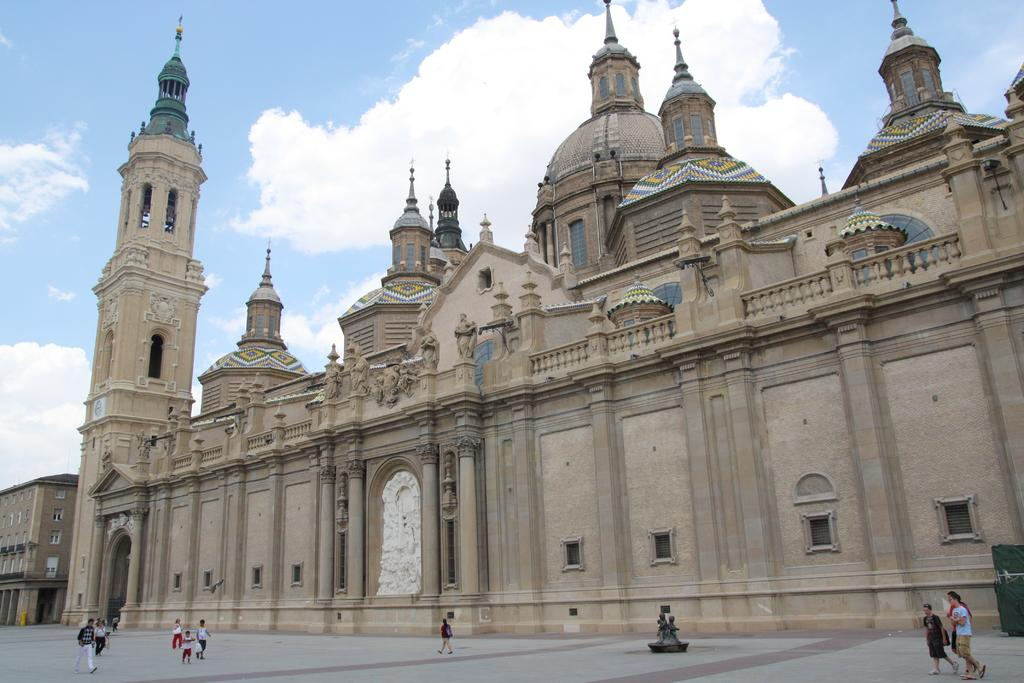What are the people in the image doing? The people in the image are walking on the road. Can you describe the background of the image? There is a building visible behind the people. What type of trick is the person performing with the sack in the image? There is no person performing a trick with a sack in the image; it only shows people walking on the road and a building in the background. 